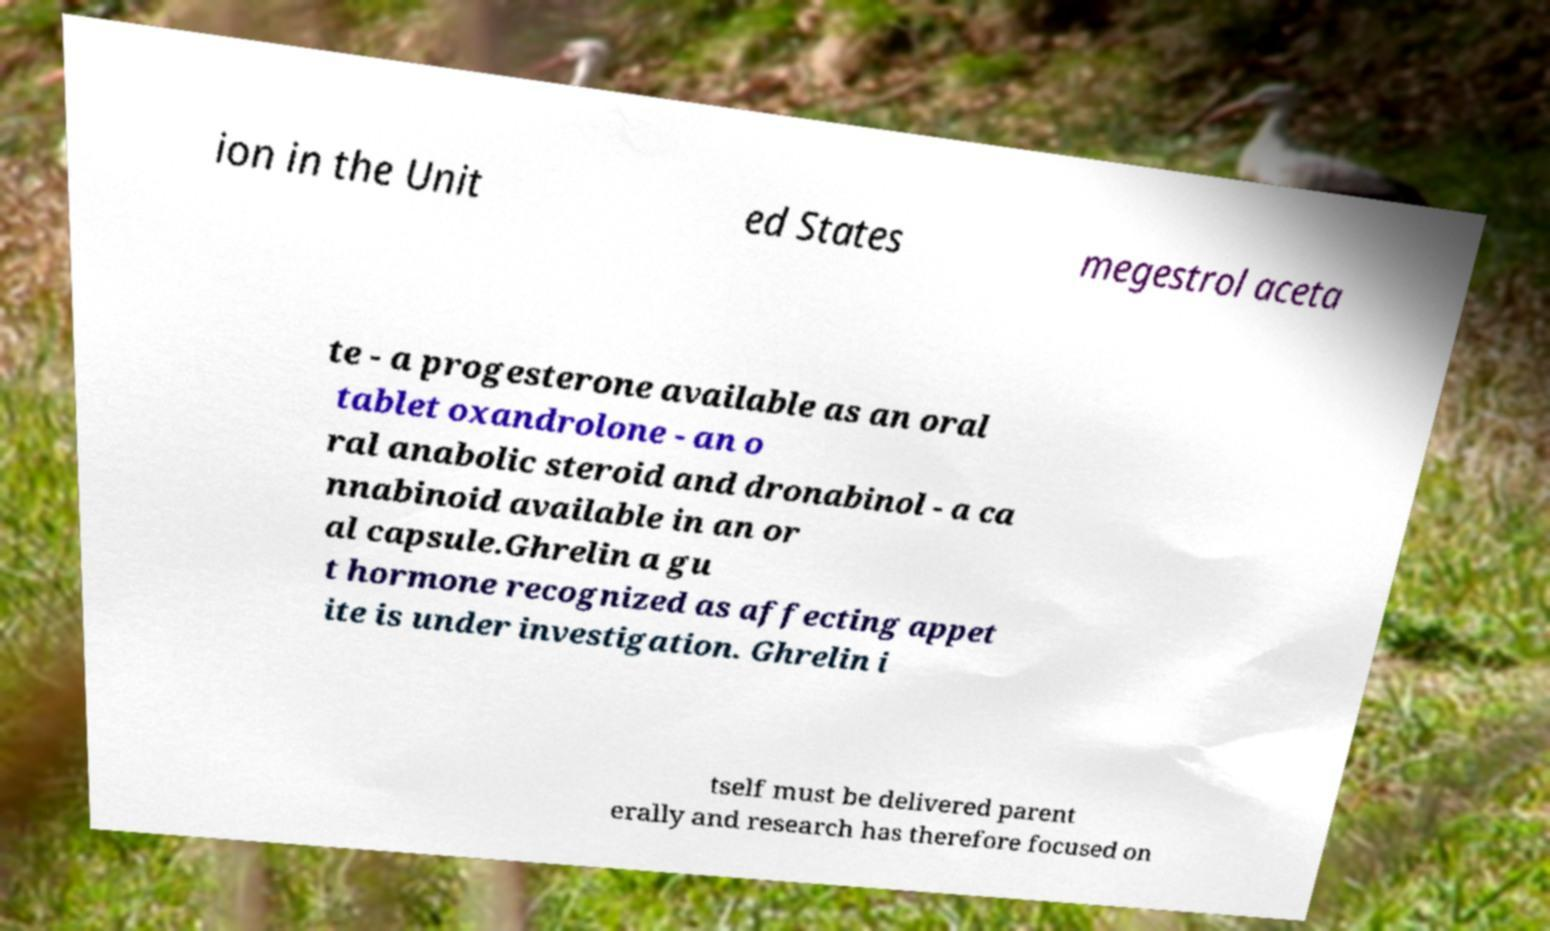Please identify and transcribe the text found in this image. ion in the Unit ed States megestrol aceta te - a progesterone available as an oral tablet oxandrolone - an o ral anabolic steroid and dronabinol - a ca nnabinoid available in an or al capsule.Ghrelin a gu t hormone recognized as affecting appet ite is under investigation. Ghrelin i tself must be delivered parent erally and research has therefore focused on 